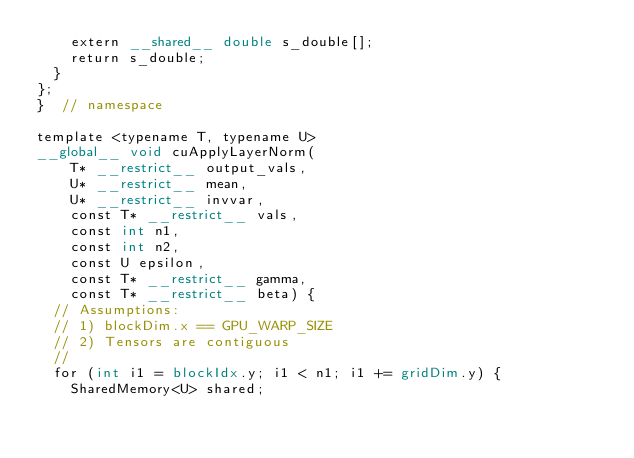<code> <loc_0><loc_0><loc_500><loc_500><_Cuda_>    extern __shared__ double s_double[];
    return s_double;
  }
};
}  // namespace

template <typename T, typename U>
__global__ void cuApplyLayerNorm(
    T* __restrict__ output_vals,
    U* __restrict__ mean,
    U* __restrict__ invvar,
    const T* __restrict__ vals,
    const int n1,
    const int n2,
    const U epsilon,
    const T* __restrict__ gamma,
    const T* __restrict__ beta) {
  // Assumptions:
  // 1) blockDim.x == GPU_WARP_SIZE
  // 2) Tensors are contiguous
  //
  for (int i1 = blockIdx.y; i1 < n1; i1 += gridDim.y) {
    SharedMemory<U> shared;</code> 